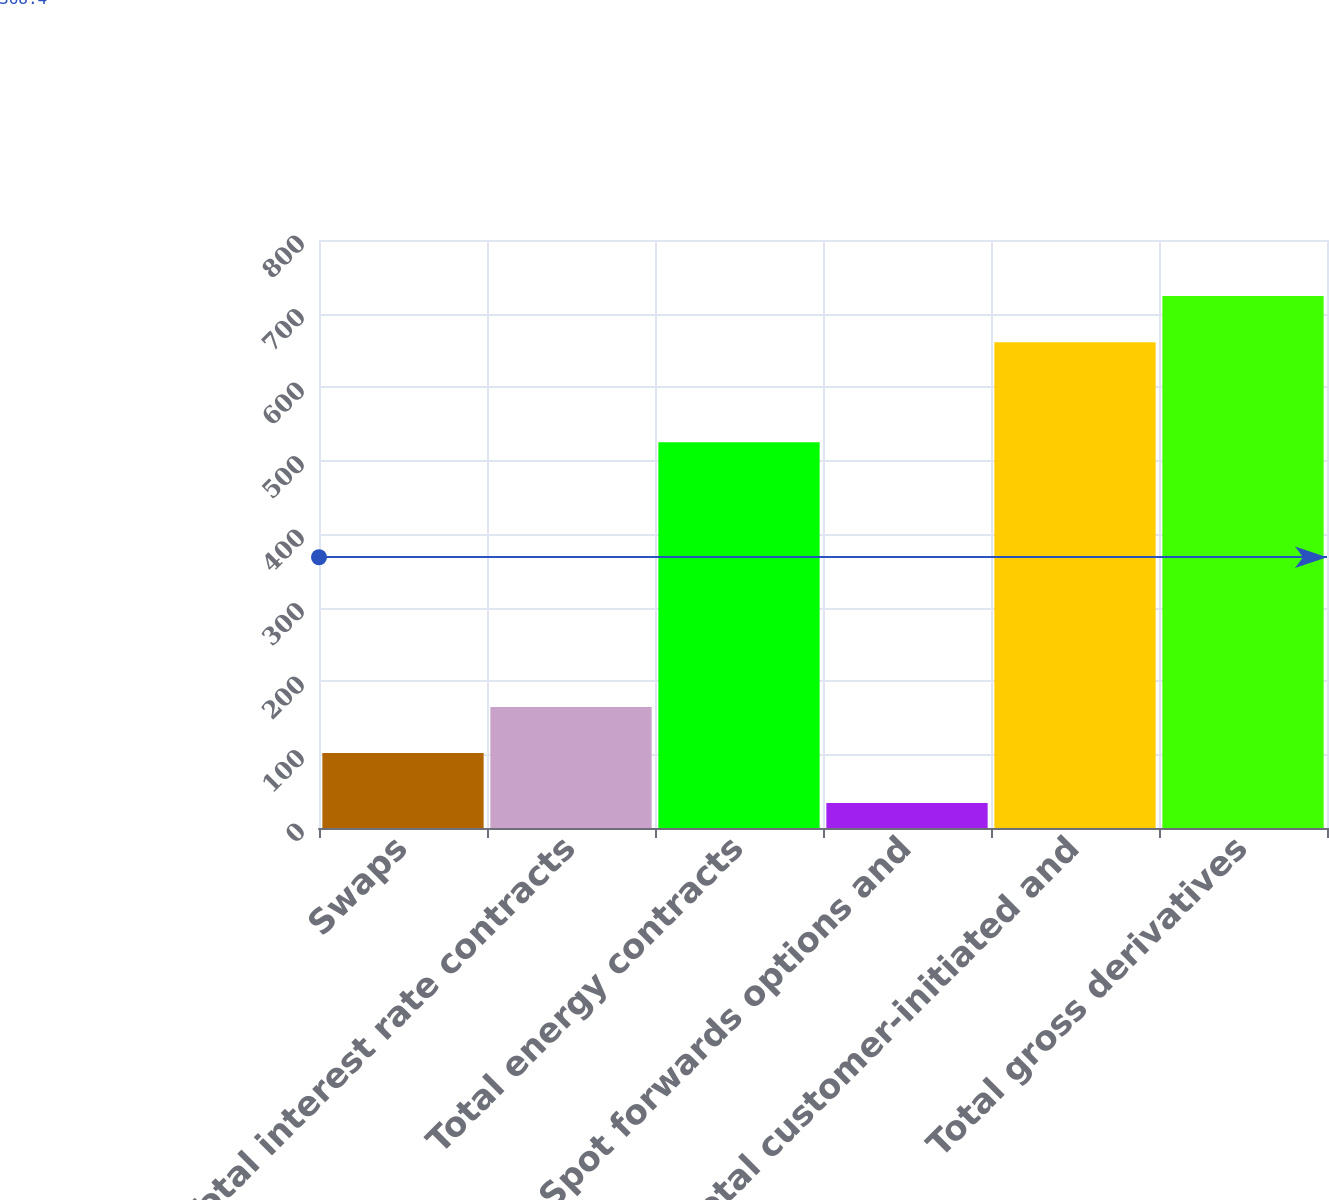<chart> <loc_0><loc_0><loc_500><loc_500><bar_chart><fcel>Swaps<fcel>Total interest rate contracts<fcel>Total energy contracts<fcel>Spot forwards options and<fcel>Total customer-initiated and<fcel>Total gross derivatives<nl><fcel>102<fcel>164.7<fcel>525<fcel>34<fcel>661<fcel>723.7<nl></chart> 